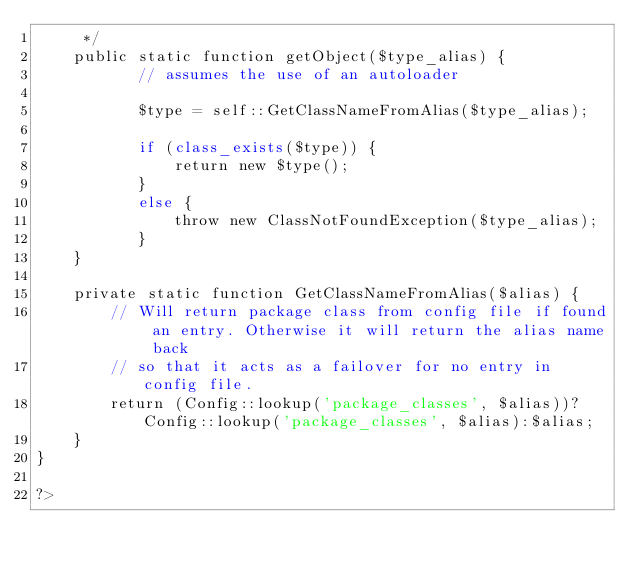Convert code to text. <code><loc_0><loc_0><loc_500><loc_500><_PHP_>	 */
	public static function getObject($type_alias) {
		   // assumes the use of an autoloader
		   
		   $type = self::GetClassNameFromAlias($type_alias);
		   
		   if (class_exists($type)) {
			   return new $type();
		   }
		   else {
			   throw new ClassNotFoundException($type_alias);
		   }
	} 
	
	private static function GetClassNameFromAlias($alias) {
		// Will return package class from config file if found an entry. Otherwise it will return the alias name back
		// so that it acts as a failover for no entry in config file.
		return (Config::lookup('package_classes', $alias))?Config::lookup('package_classes', $alias):$alias;
	}
}

?>
</code> 